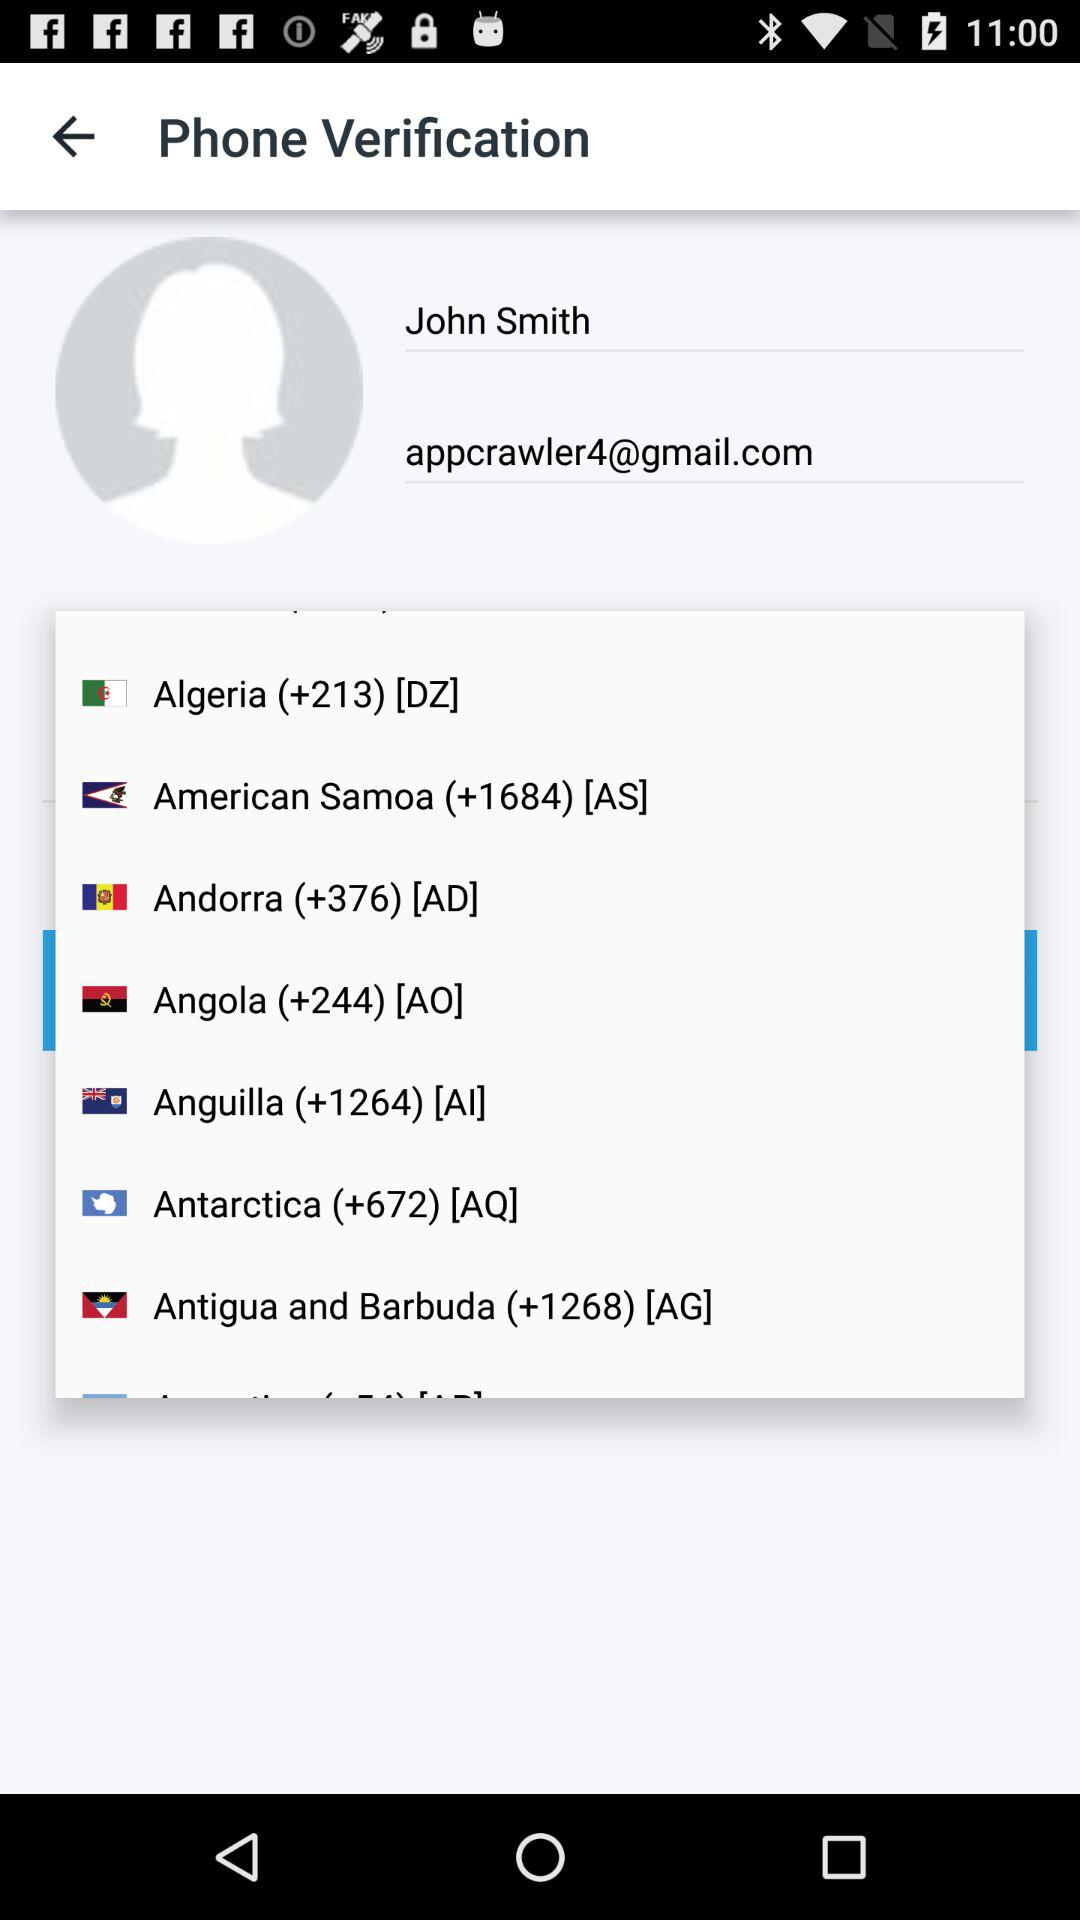What are the countries that I can select? The countries are "Algeria", "American Samoa", "Andorra", "Angola", "Anguilla", "Antarctica" and "Antigua and Barbuda". 